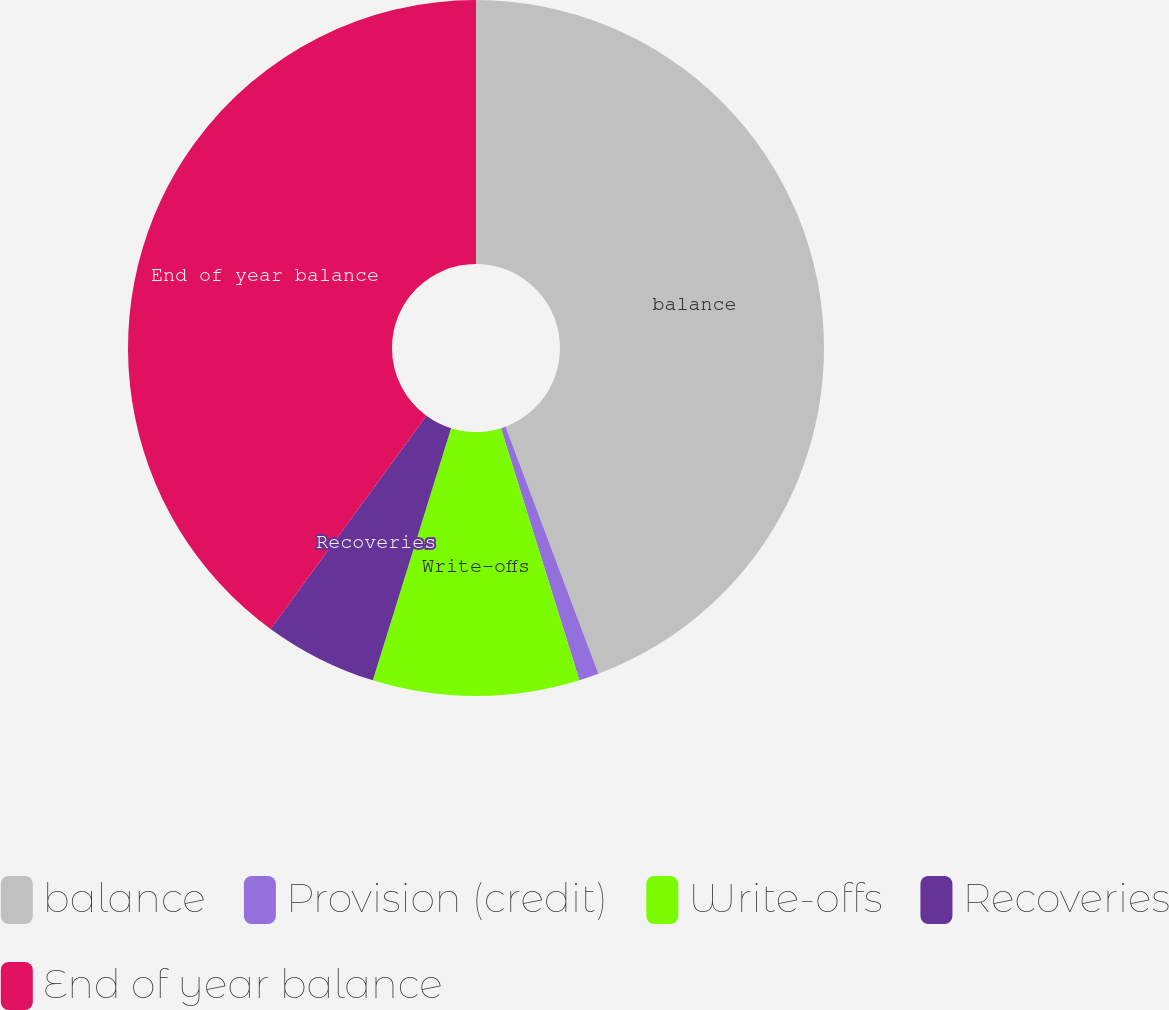<chart> <loc_0><loc_0><loc_500><loc_500><pie_chart><fcel>balance<fcel>Provision (credit)<fcel>Write-offs<fcel>Recoveries<fcel>End of year balance<nl><fcel>44.28%<fcel>0.92%<fcel>9.59%<fcel>5.26%<fcel>39.95%<nl></chart> 